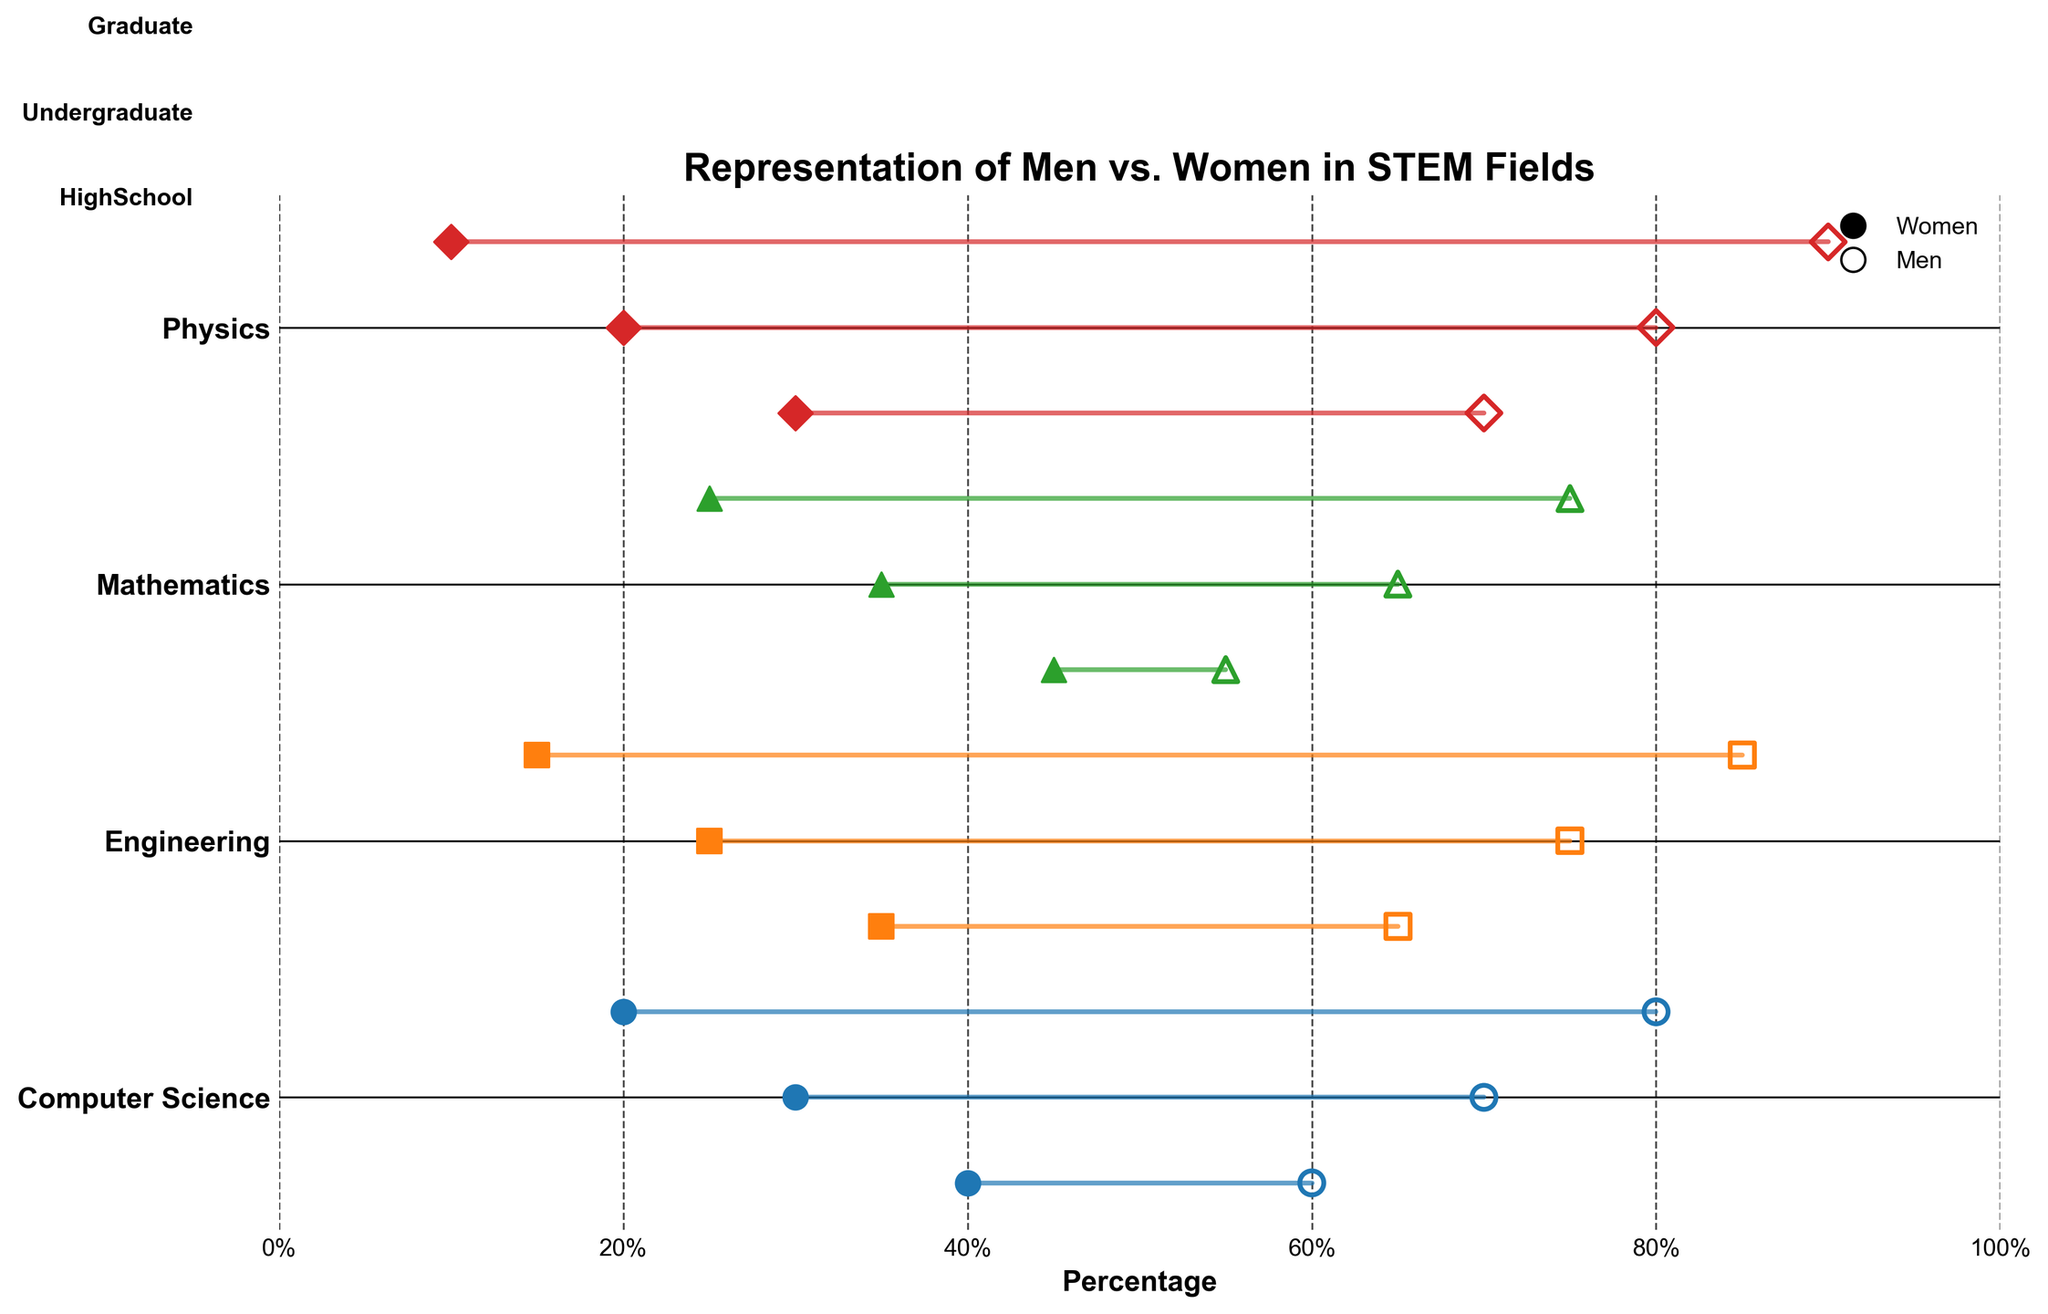What's the title of the plot? The title is usually found at the top of the plot and provides a summary of what the plot is about. In this case, the title is "Representation of Men vs. Women in STEM Fields".
Answer: Representation of Men vs. Women in STEM Fields What are the educational levels represented on the plot? The educational levels are labeled along one axis and are typically 'HighSchool', 'Undergraduate', and 'Graduate' as per the data provided. These levels describe the stages of education for which the data on gender representation has been plotted.
Answer: HighSchool, Undergraduate, Graduate Which STEM field has the largest gap in representation between men and women at the Graduate level? Look for the longest horizontal line segment (dumbbell) at the Graduate level. This indicates the largest difference between the percentages of men and women. For the field 'Physics', the gap is from 90% (men) to 10% (women), which is a difference of 80%.
Answer: Physics In which STEM field is the representation of women higher at the HighSchool level compared to other fields? Examine the HighSchool data points for women across all fields and identify the highest percentage. In 'Mathematics', 45% of high schoolers are women, which is the highest among all STEM fields.
Answer: Mathematics Compare the UnderGraduate representation of men and women in Engineering. Look at the positions of the markers for men and women in the 'Engineering' field at the UnderGraduate level. Men are at 75%, and women are at 25%, indicating a gap of 50%.
Answer: 75% men, 25% women Which field shows the smallest gender gap at the HighSchool level? Identify the shortest line segment (dumbbell) at the HighSchool level across all fields. In 'Mathematics', the gap is from 55% (men) to 45% (women), a difference of 10%.
Answer: Mathematics What is the difference in the representation of men and women in Computer Science at the Graduate level? Identify the data points for men and women in 'Computer Science' at the Graduate level. The percentages are 80% for men and 20% for women, making the difference 60%.
Answer: 60% How does women’s representation change from HighSchool to Graduate level in Physics? Look at the markers for women in Physics across the three educational levels. Women’s representation decreases from 30% at HighSchool to 20% at Undergraduate and finally to 10% at Graduate. The overall decrease is 20% from HighSchool to Graduate.
Answer: Decreases by 20% What is the average representation of men in Computer Science across all educational levels? Calculate the average by adding the percentages of men at each education level in Computer Science (60% at HighSchool, 70% at Undergraduate, 80% at Graduate) and then dividing by 3. (60 + 70 + 80) / 3 = 70%.
Answer: 70% Name all the STEM fields where the representation of men in Graduate level is more than 50%. Compare the Graduate level data points for men across all fields. In all four fields: Computer Science (80%), Engineering (85%), Mathematics (75%), and Physics (90%), the representation exceeds 50%.
Answer: Computer Science, Engineering, Mathematics, Physics 